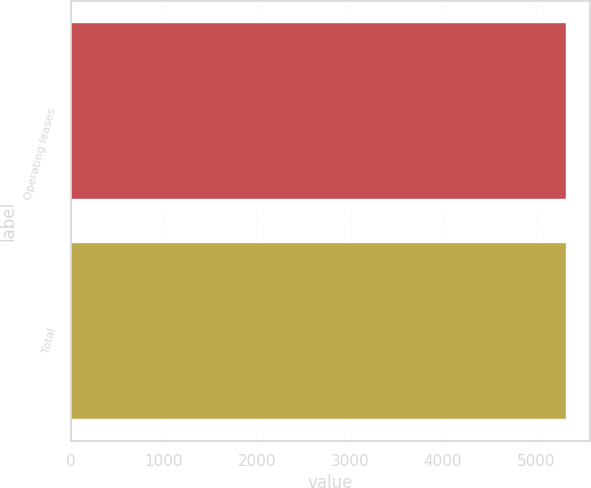<chart> <loc_0><loc_0><loc_500><loc_500><bar_chart><fcel>Operating leases<fcel>Total<nl><fcel>5320<fcel>5320.1<nl></chart> 